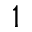<formula> <loc_0><loc_0><loc_500><loc_500>^ { 1 }</formula> 